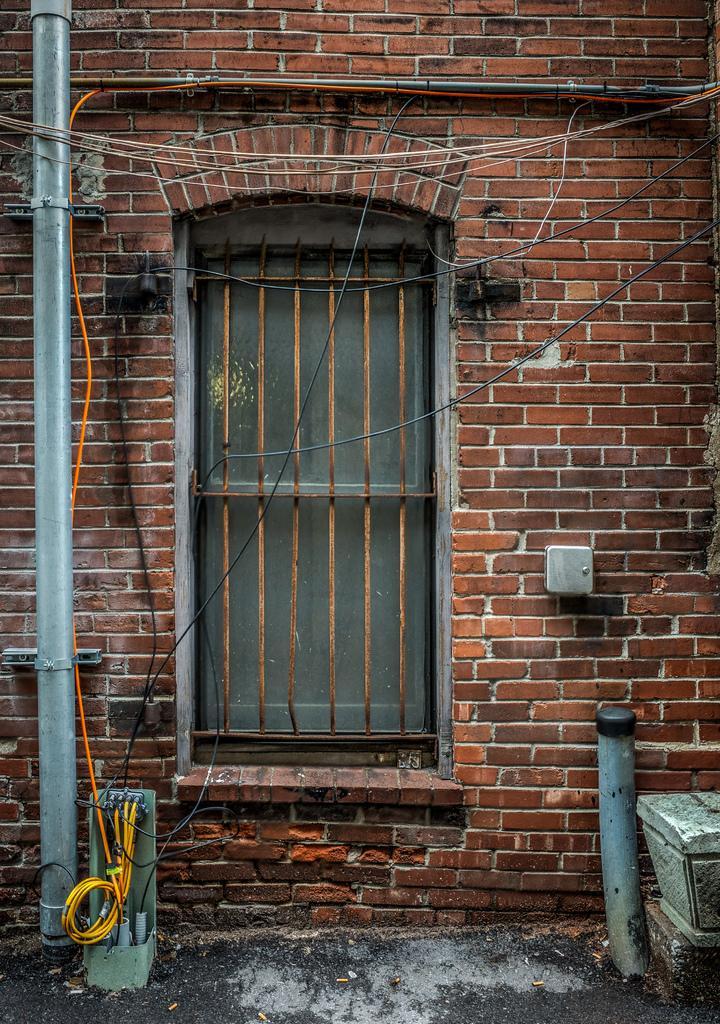Describe this image in one or two sentences. In this image we can see brick wall and window. Left side of the image pole and wires are present. Right side of the image circular thing and white color thing is present. 